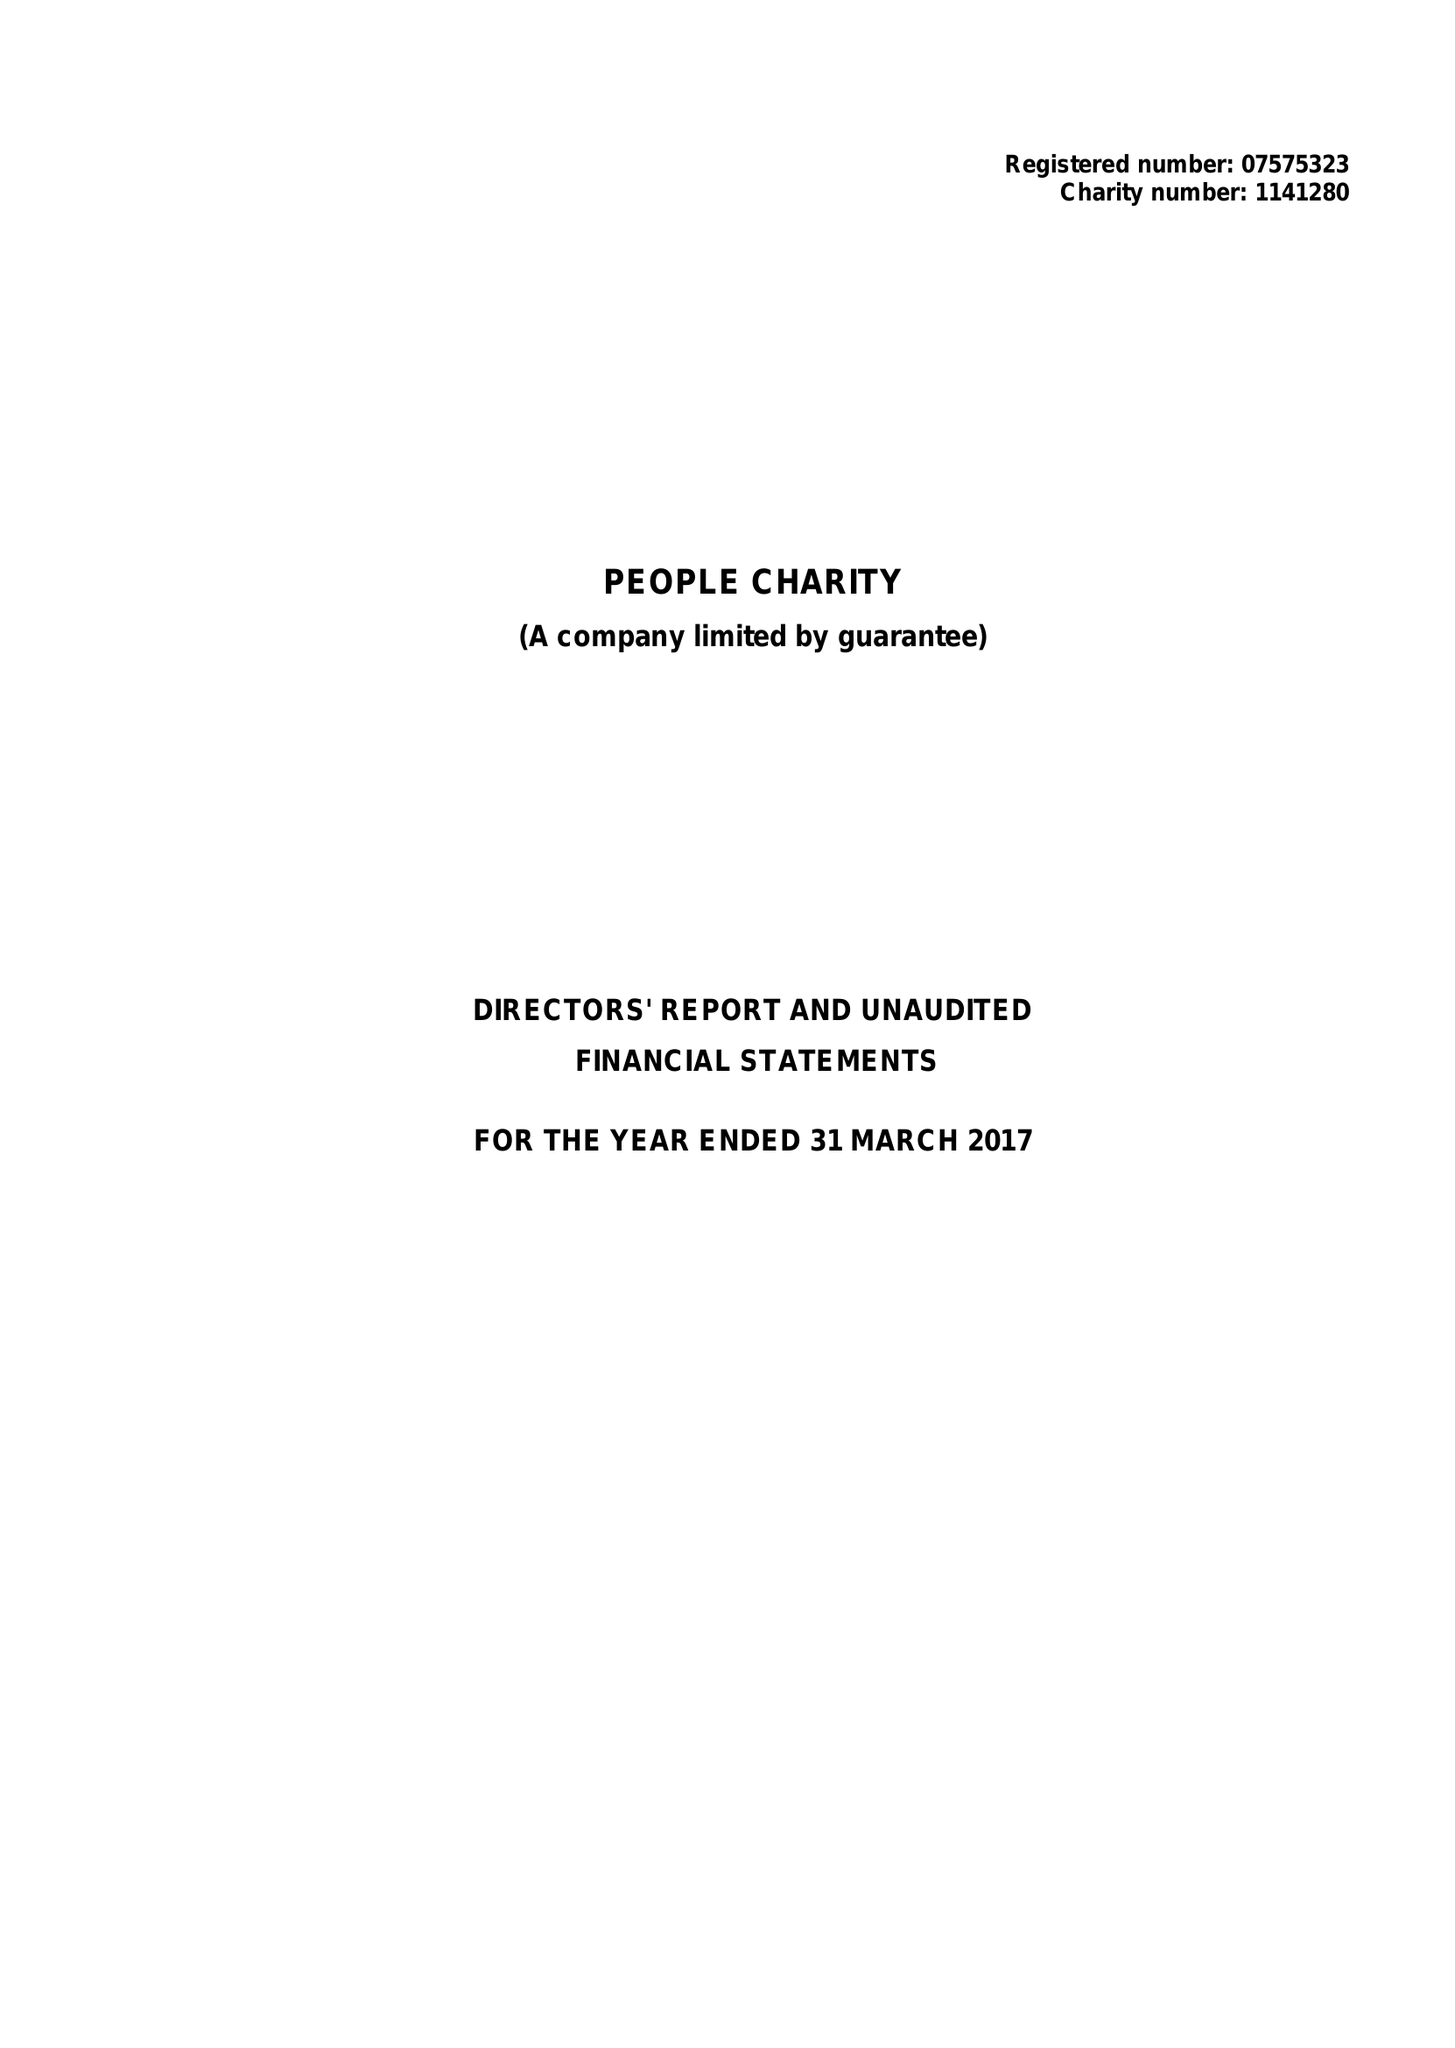What is the value for the report_date?
Answer the question using a single word or phrase. 2017-03-31 